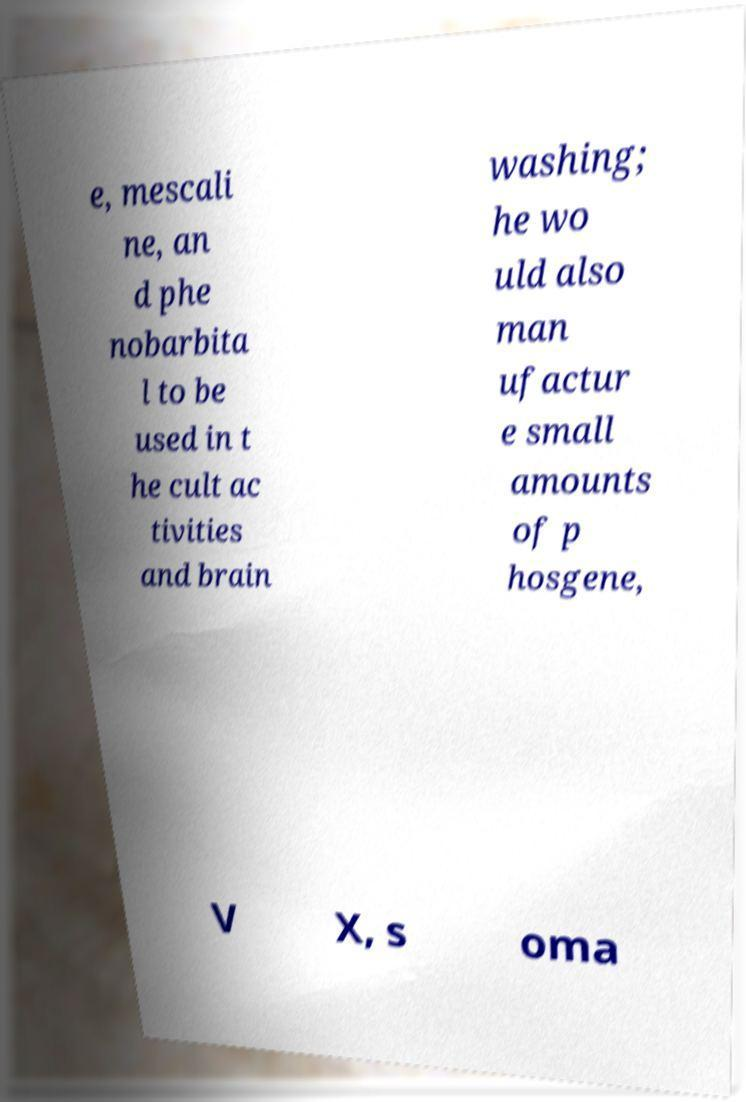What messages or text are displayed in this image? I need them in a readable, typed format. e, mescali ne, an d phe nobarbita l to be used in t he cult ac tivities and brain washing; he wo uld also man ufactur e small amounts of p hosgene, V X, s oma 